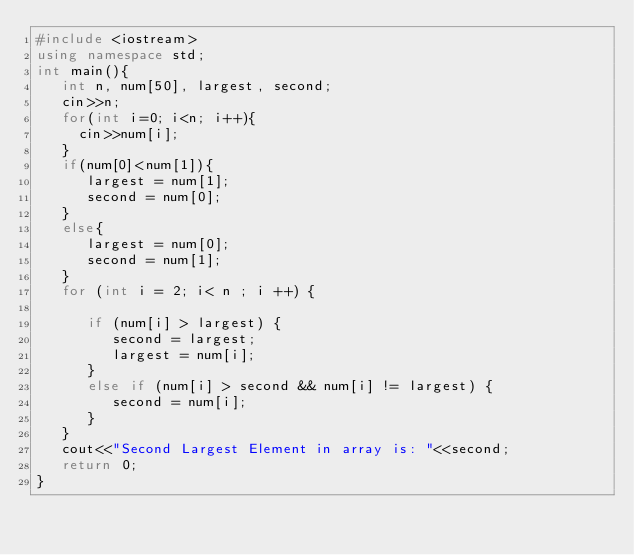<code> <loc_0><loc_0><loc_500><loc_500><_C++_>#include <iostream>
using namespace std;
int main(){
   int n, num[50], largest, second;
   cin>>n;
   for(int i=0; i<n; i++){
     cin>>num[i];
   }
   if(num[0]<num[1]){ 
      largest = num[1];
      second = num[0];
   }
   else{ 
      largest = num[0];
      second = num[1];
   }
   for (int i = 2; i< n ; i ++) {
      
      if (num[i] > largest) {
         second = largest;
         largest = num[i];
      }
      else if (num[i] > second && num[i] != largest) {
         second = num[i];
      }
   }
   cout<<"Second Largest Element in array is: "<<second;
   return 0;
}
</code> 